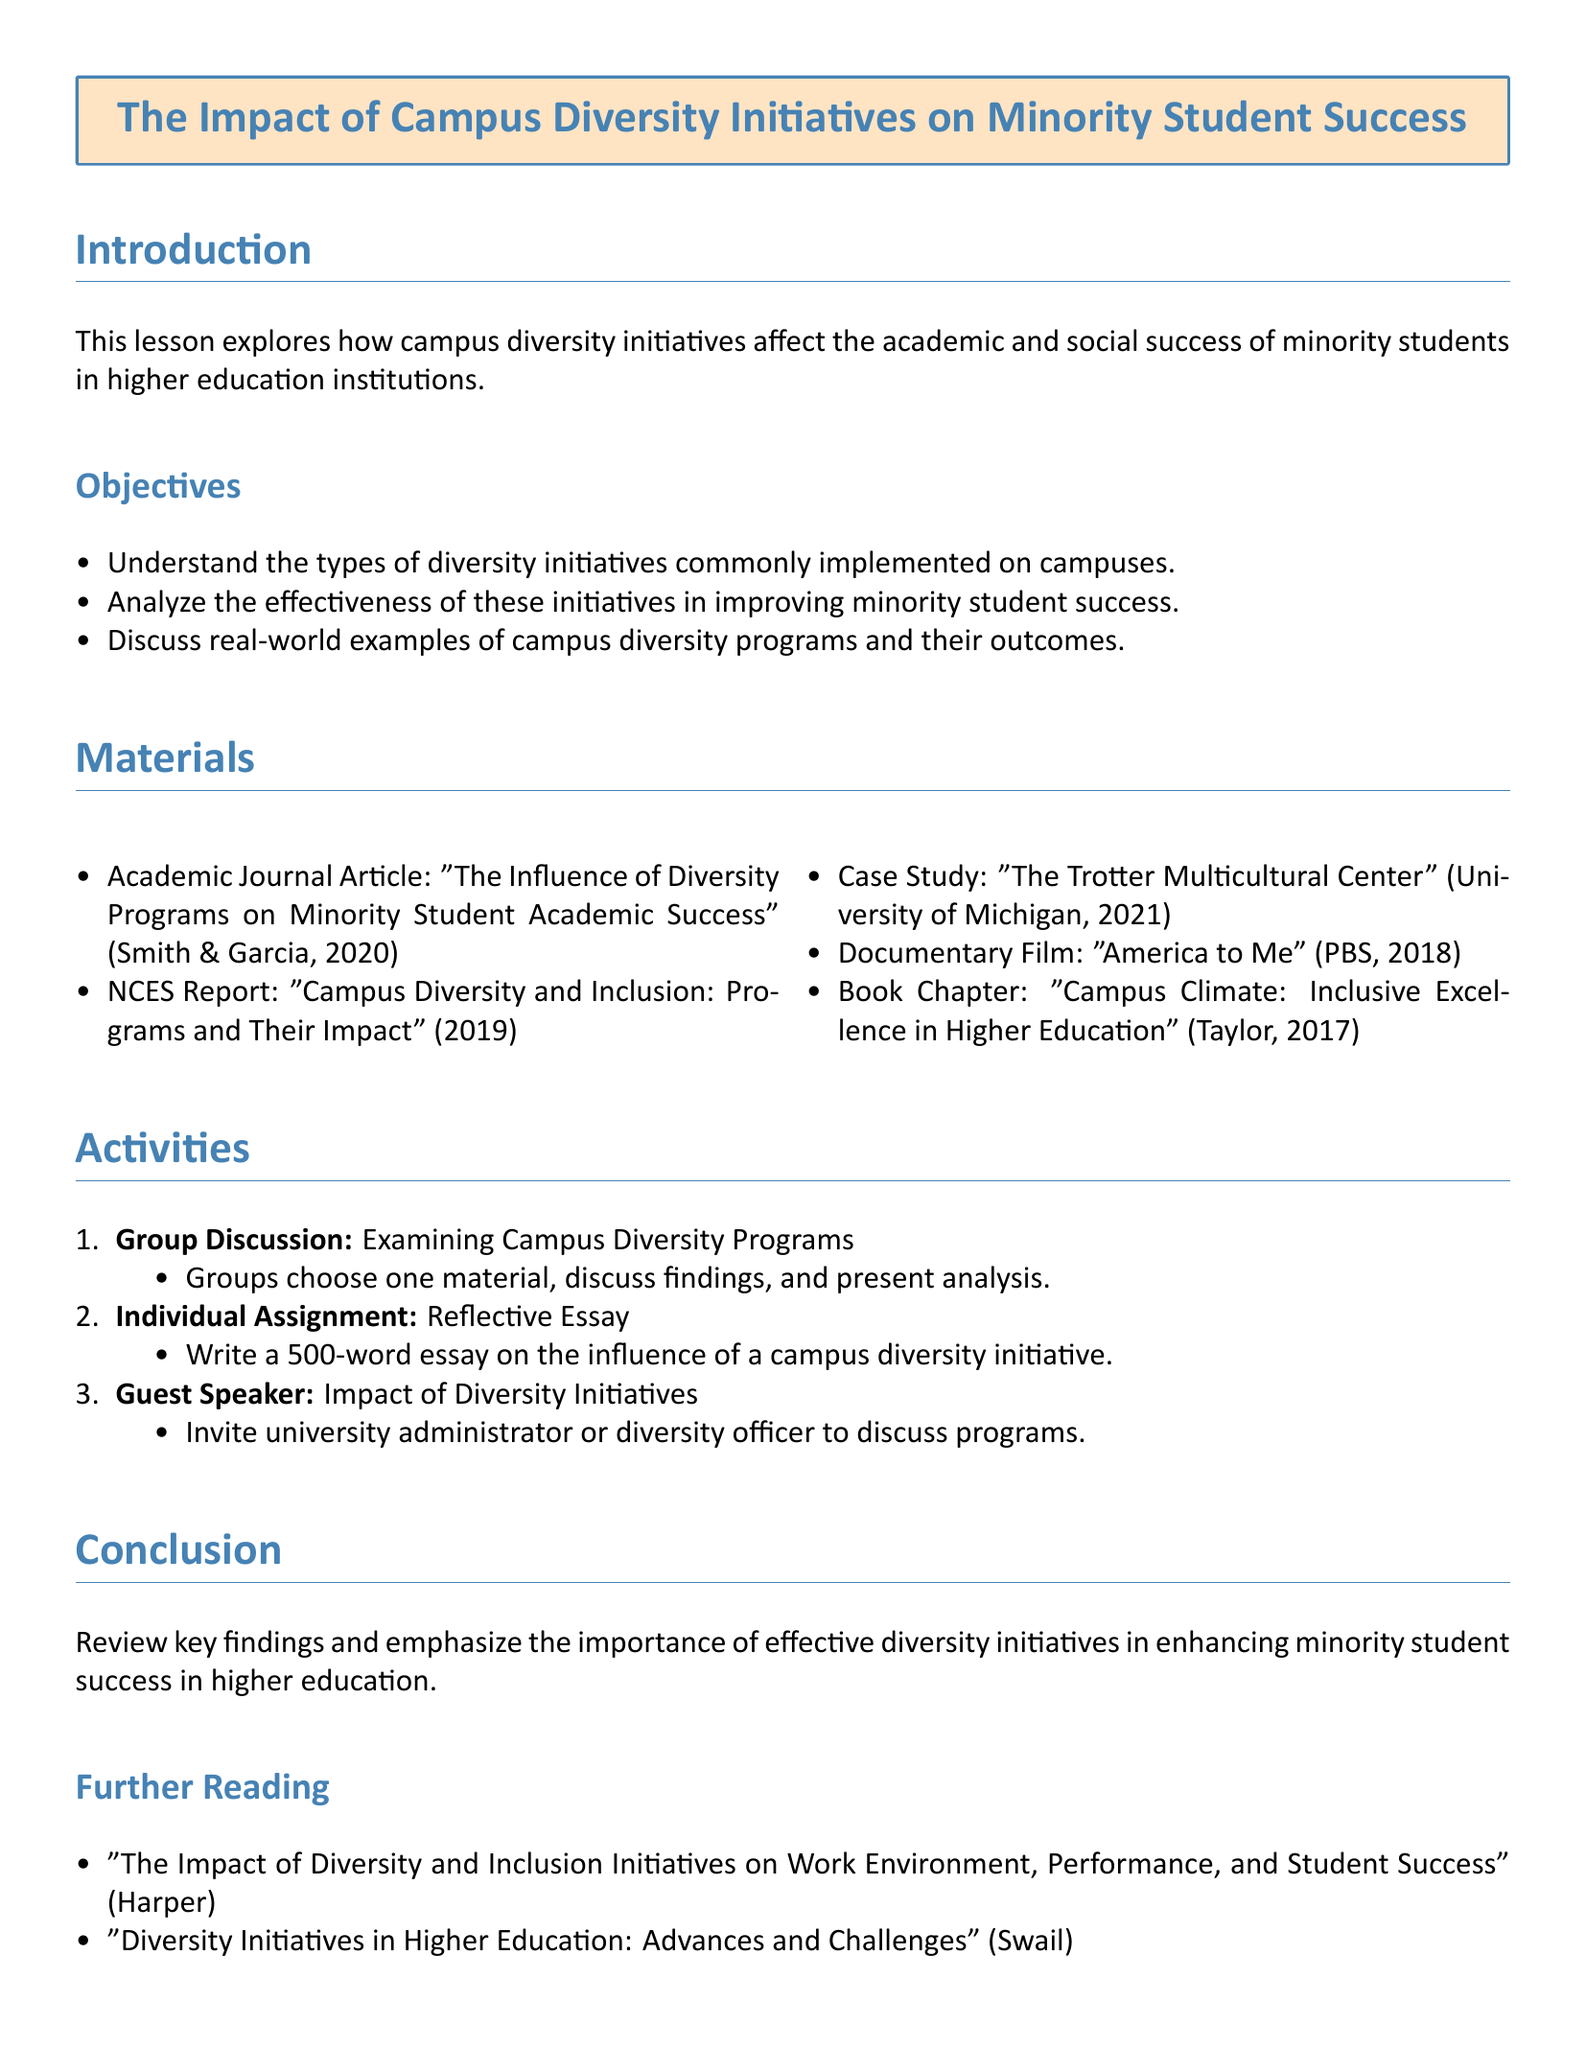What is the main topic of the lesson? The main topic is stated at the top of the document, focusing on how diversity initiatives impact minority students.
Answer: The Impact of Campus Diversity Initiatives on Minority Student Success What year was the NCES report published? The publication year for the NCES report is mentioned under the materials section.
Answer: 2019 Who are the authors of the academic journal article? The authors of the article are provided in the materials section.
Answer: Smith & Garcia How many objectives are listed in the lesson plan? The number of objectives can be counted in the objectives section.
Answer: 3 What type of assignment is included for individual work? The specific type of assignment is mentioned in the activities section for individual work.
Answer: Reflective Essay What is the total number of materials listed in the lesson plan? The count of different materials provided in the materials section can be noted.
Answer: 5 Who is suggested as a guest speaker? The type of guest speaker is indicated in the activities section.
Answer: University administrator or diversity officer What is the required word count for the reflective essay? The specific word count for the essay is mentioned in the individual assignment section.
Answer: 500 What is emphasized in the conclusion? The conclusion section highlights a key finding regarding diversity initiatives.
Answer: Importance of effective diversity initiatives 